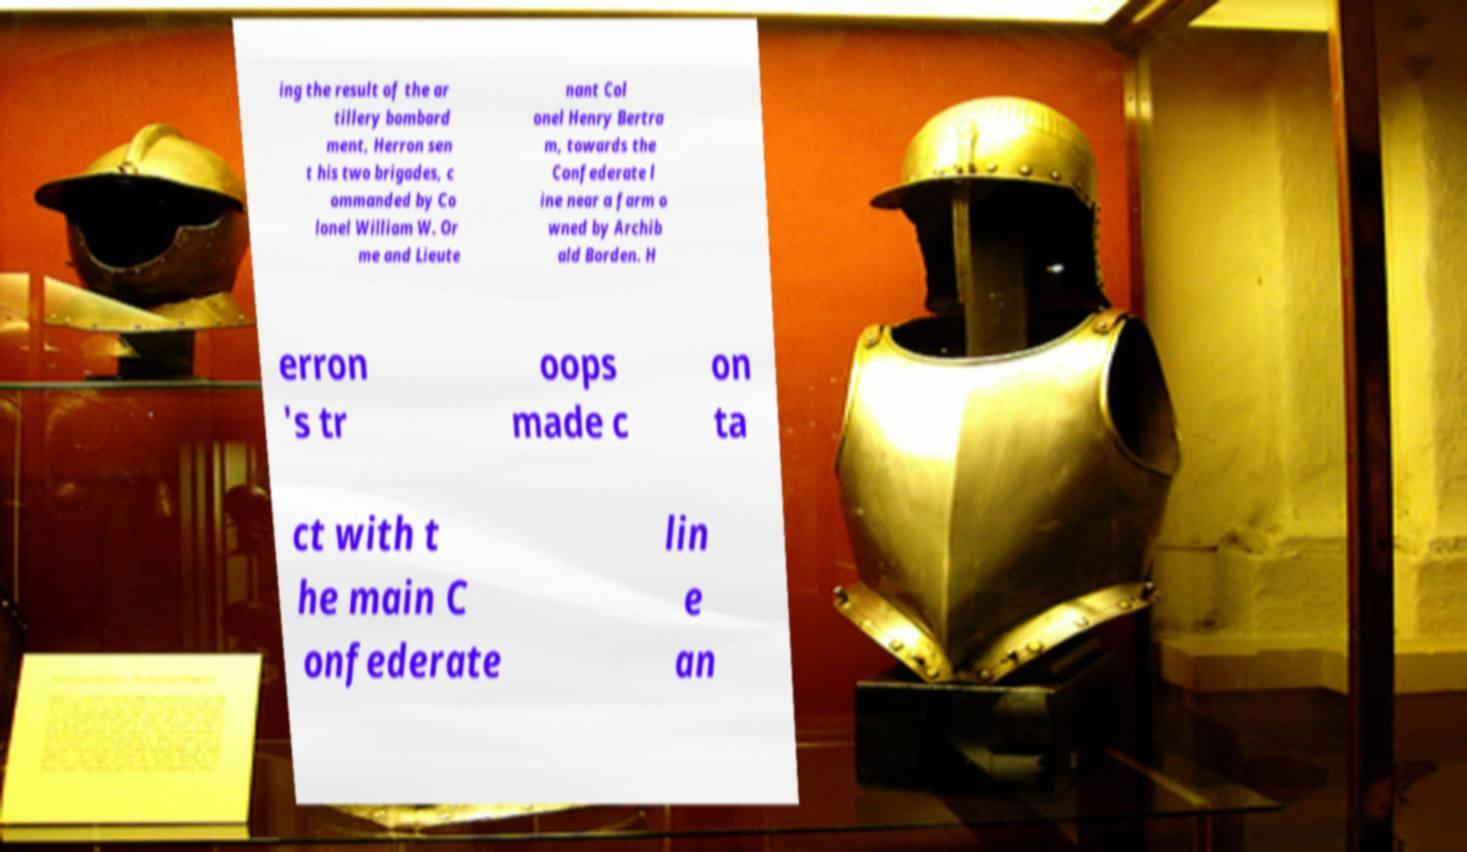What messages or text are displayed in this image? I need them in a readable, typed format. ing the result of the ar tillery bombard ment, Herron sen t his two brigades, c ommanded by Co lonel William W. Or me and Lieute nant Col onel Henry Bertra m, towards the Confederate l ine near a farm o wned by Archib ald Borden. H erron 's tr oops made c on ta ct with t he main C onfederate lin e an 